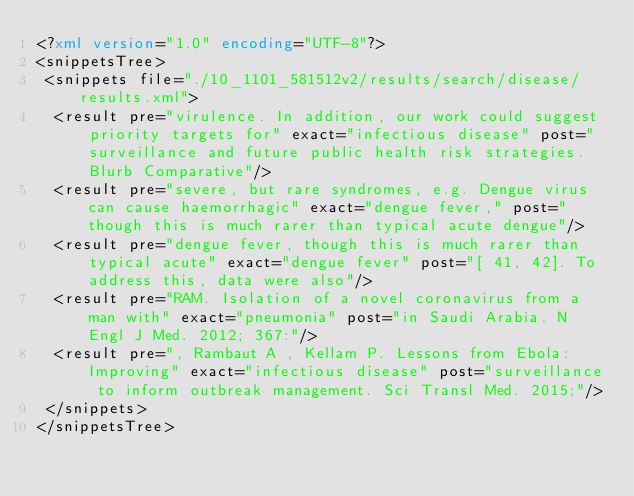<code> <loc_0><loc_0><loc_500><loc_500><_XML_><?xml version="1.0" encoding="UTF-8"?>
<snippetsTree>
 <snippets file="./10_1101_581512v2/results/search/disease/results.xml">
  <result pre="virulence. In addition, our work could suggest priority targets for" exact="infectious disease" post="surveillance and future public health risk strategies. Blurb Comparative"/>
  <result pre="severe, but rare syndromes, e.g. Dengue virus can cause haemorrhagic" exact="dengue fever," post="though this is much rarer than typical acute dengue"/>
  <result pre="dengue fever, though this is much rarer than typical acute" exact="dengue fever" post="[ 41, 42]. To address this, data were also"/>
  <result pre="RAM. Isolation of a novel coronavirus from a man with" exact="pneumonia" post="in Saudi Arabia. N Engl J Med. 2012; 367:"/>
  <result pre=", Rambaut A , Kellam P. Lessons from Ebola: Improving" exact="infectious disease" post="surveillance to inform outbreak management. Sci Transl Med. 2015;"/>
 </snippets>
</snippetsTree>
</code> 